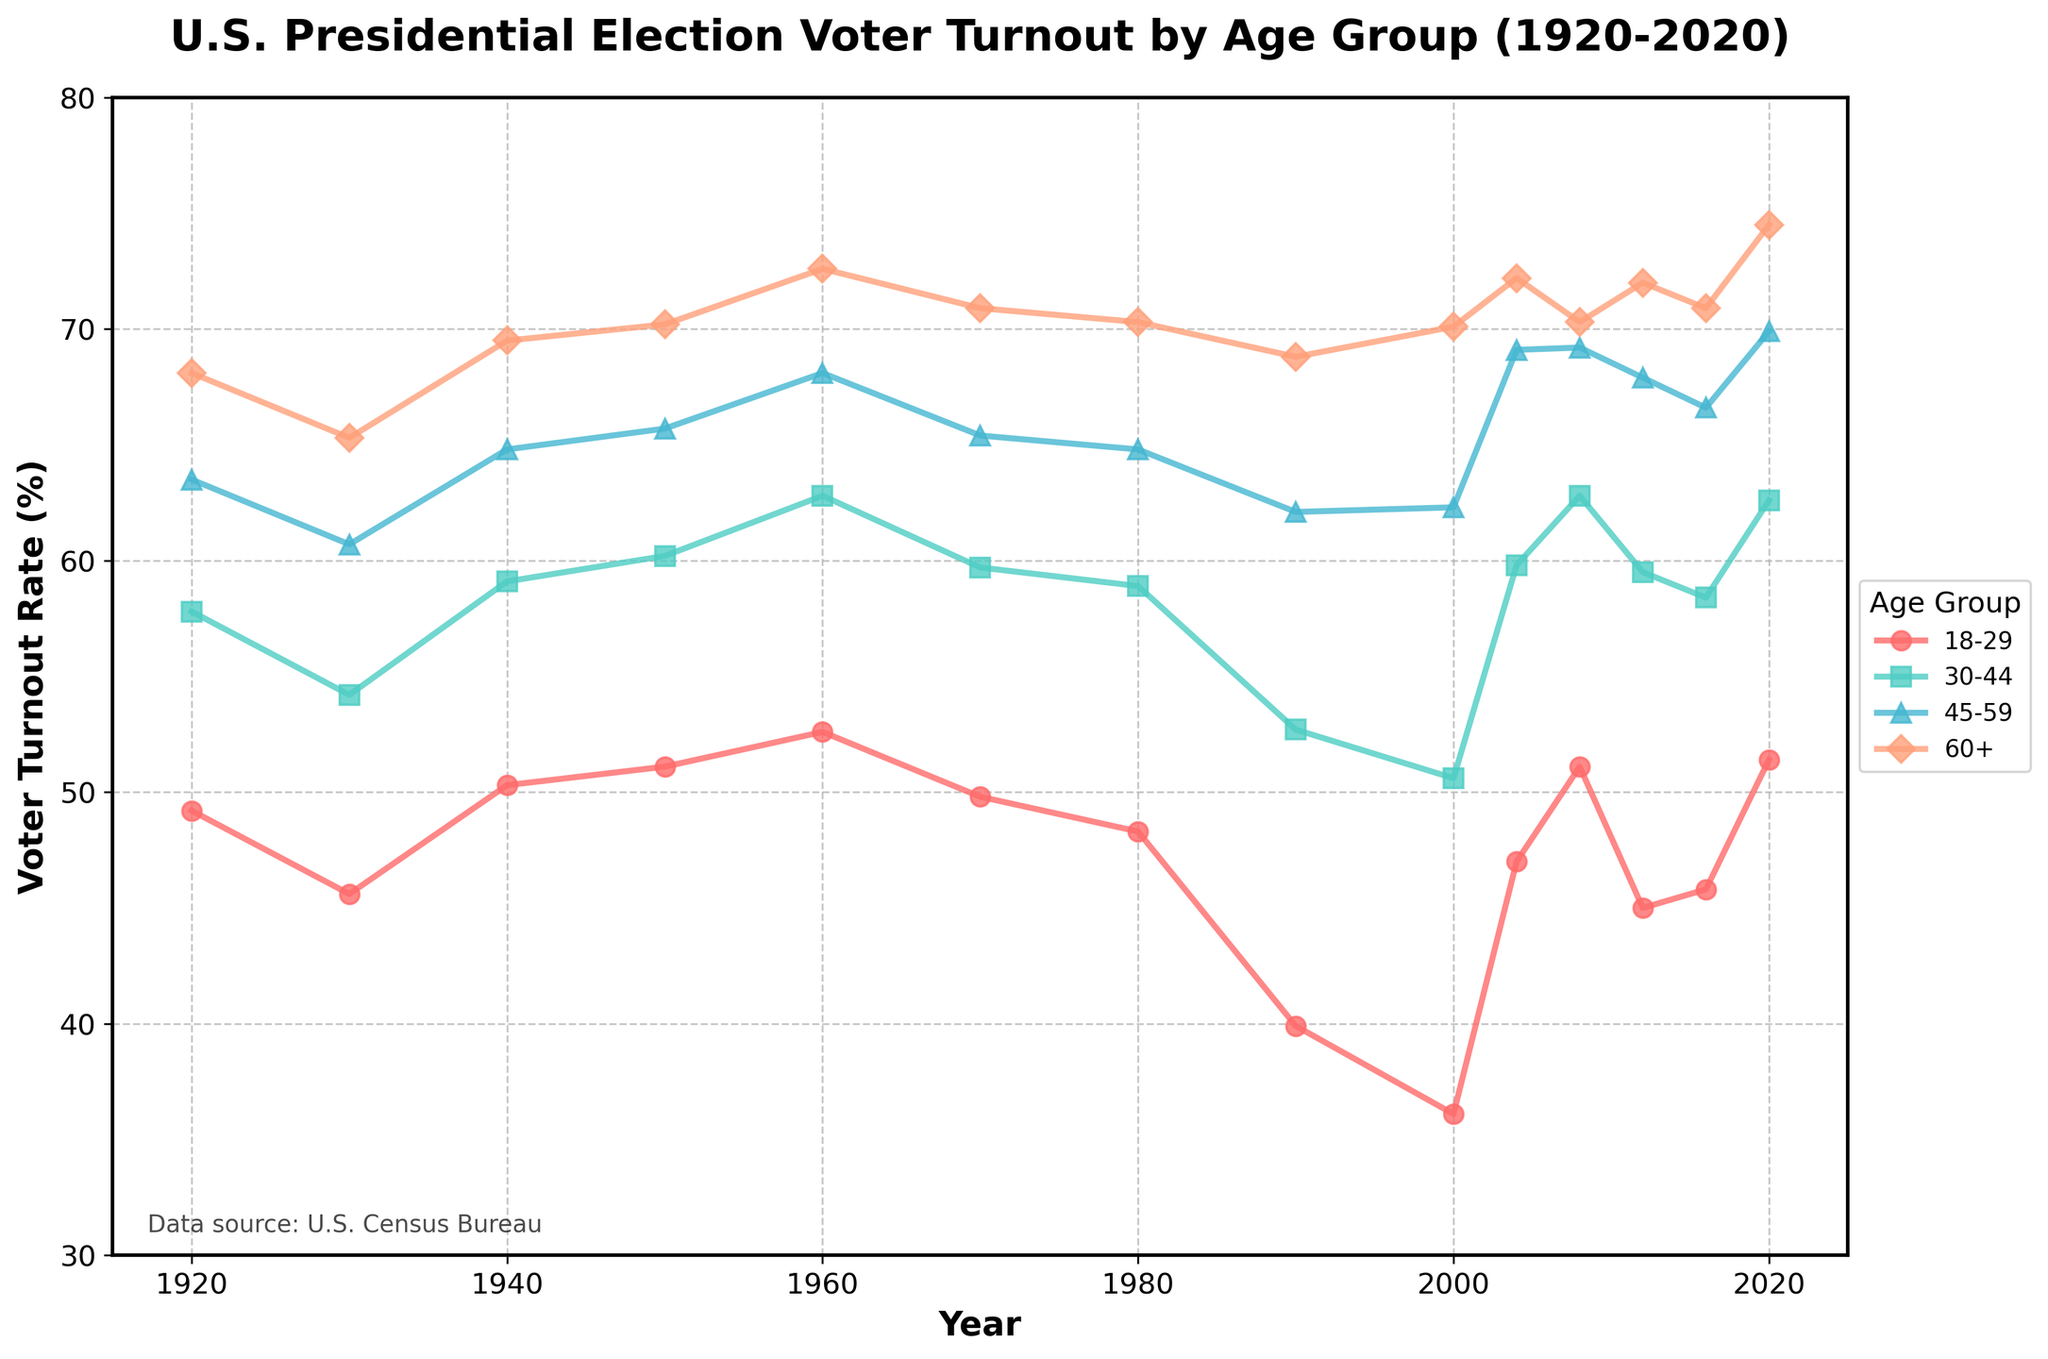What's the voter turnout rate for the 18-29 age group in 2008? To find the answer, locate the year 2008 on the x-axis and trace it upward to the 18-29 age group line, then read the value where the line intersects.
Answer: 51.1% Which age group had the highest voter turnout rate in 1940? To find the answer, locate the year 1940 on the x-axis and compare the heights of all four age group lines. The highest line corresponds to the highest voter turnout rate.
Answer: 60+ How does the voter turnout rate for the 18-29 age group in 2020 compare to that in 1990? To find the answer, locate the years 1990 and 2020 on the x-axis and compare the heights of the 18-29 age group line at those points.
Answer: Higher in 2020 In which year did the voter turnout rate for the 60+ age group first cross 70%? To find the answer, follow the 60+ age group line to see the year where it first rises above 70% on the y-axis.
Answer: 1950 Is the voter turnout trend for the 30-44 age group increasing or decreasing from 1930 to 1960? To find the answer, compare the values of the 30-44 age group line from 1930 to 1960 to see if it is trending upward or downward over that time period.
Answer: Increasing What is the average voter turnout rate for the 45-59 age group from 2000 to 2020? Calculate the average by adding the voter turnout rates from 2000 to 2020 and then dividing by the number of years considered. (62.3 + 69.1 + 69.2 + 67.9 + 66.6 + 69.9) / 6
Answer: 67.5% Compare the voter turnout rates between the 60+ age group and 18-29 age group in 2004. Which is higher and by how much? Locate both values in 2004 and subtract the lower value (18-29: 47.0%) from the higher value (60+: 72.2%).
Answer: 60+; 25.2% Which age group has the most stable voter turnout rate over the past century? Compare the variability in the lines of each age group. The group with the least fluctuation is the most stable.
Answer: 60+ In which decade did all age groups experience a decrease in voter turnout almost simultaneously? Identify the decade where all four age group lines show a decrease in their respective values.
Answer: 1990s How does the overall trend of voter turnout rates for the 45-59 and 60+ age groups from 1980 to 2020 compare? Compare the general directions of the 45-59 and 60+ age group lines from 1980 to 2020 to see if they are both increasing, decreasing, or have mixed trends.
Answer: Both increasing 